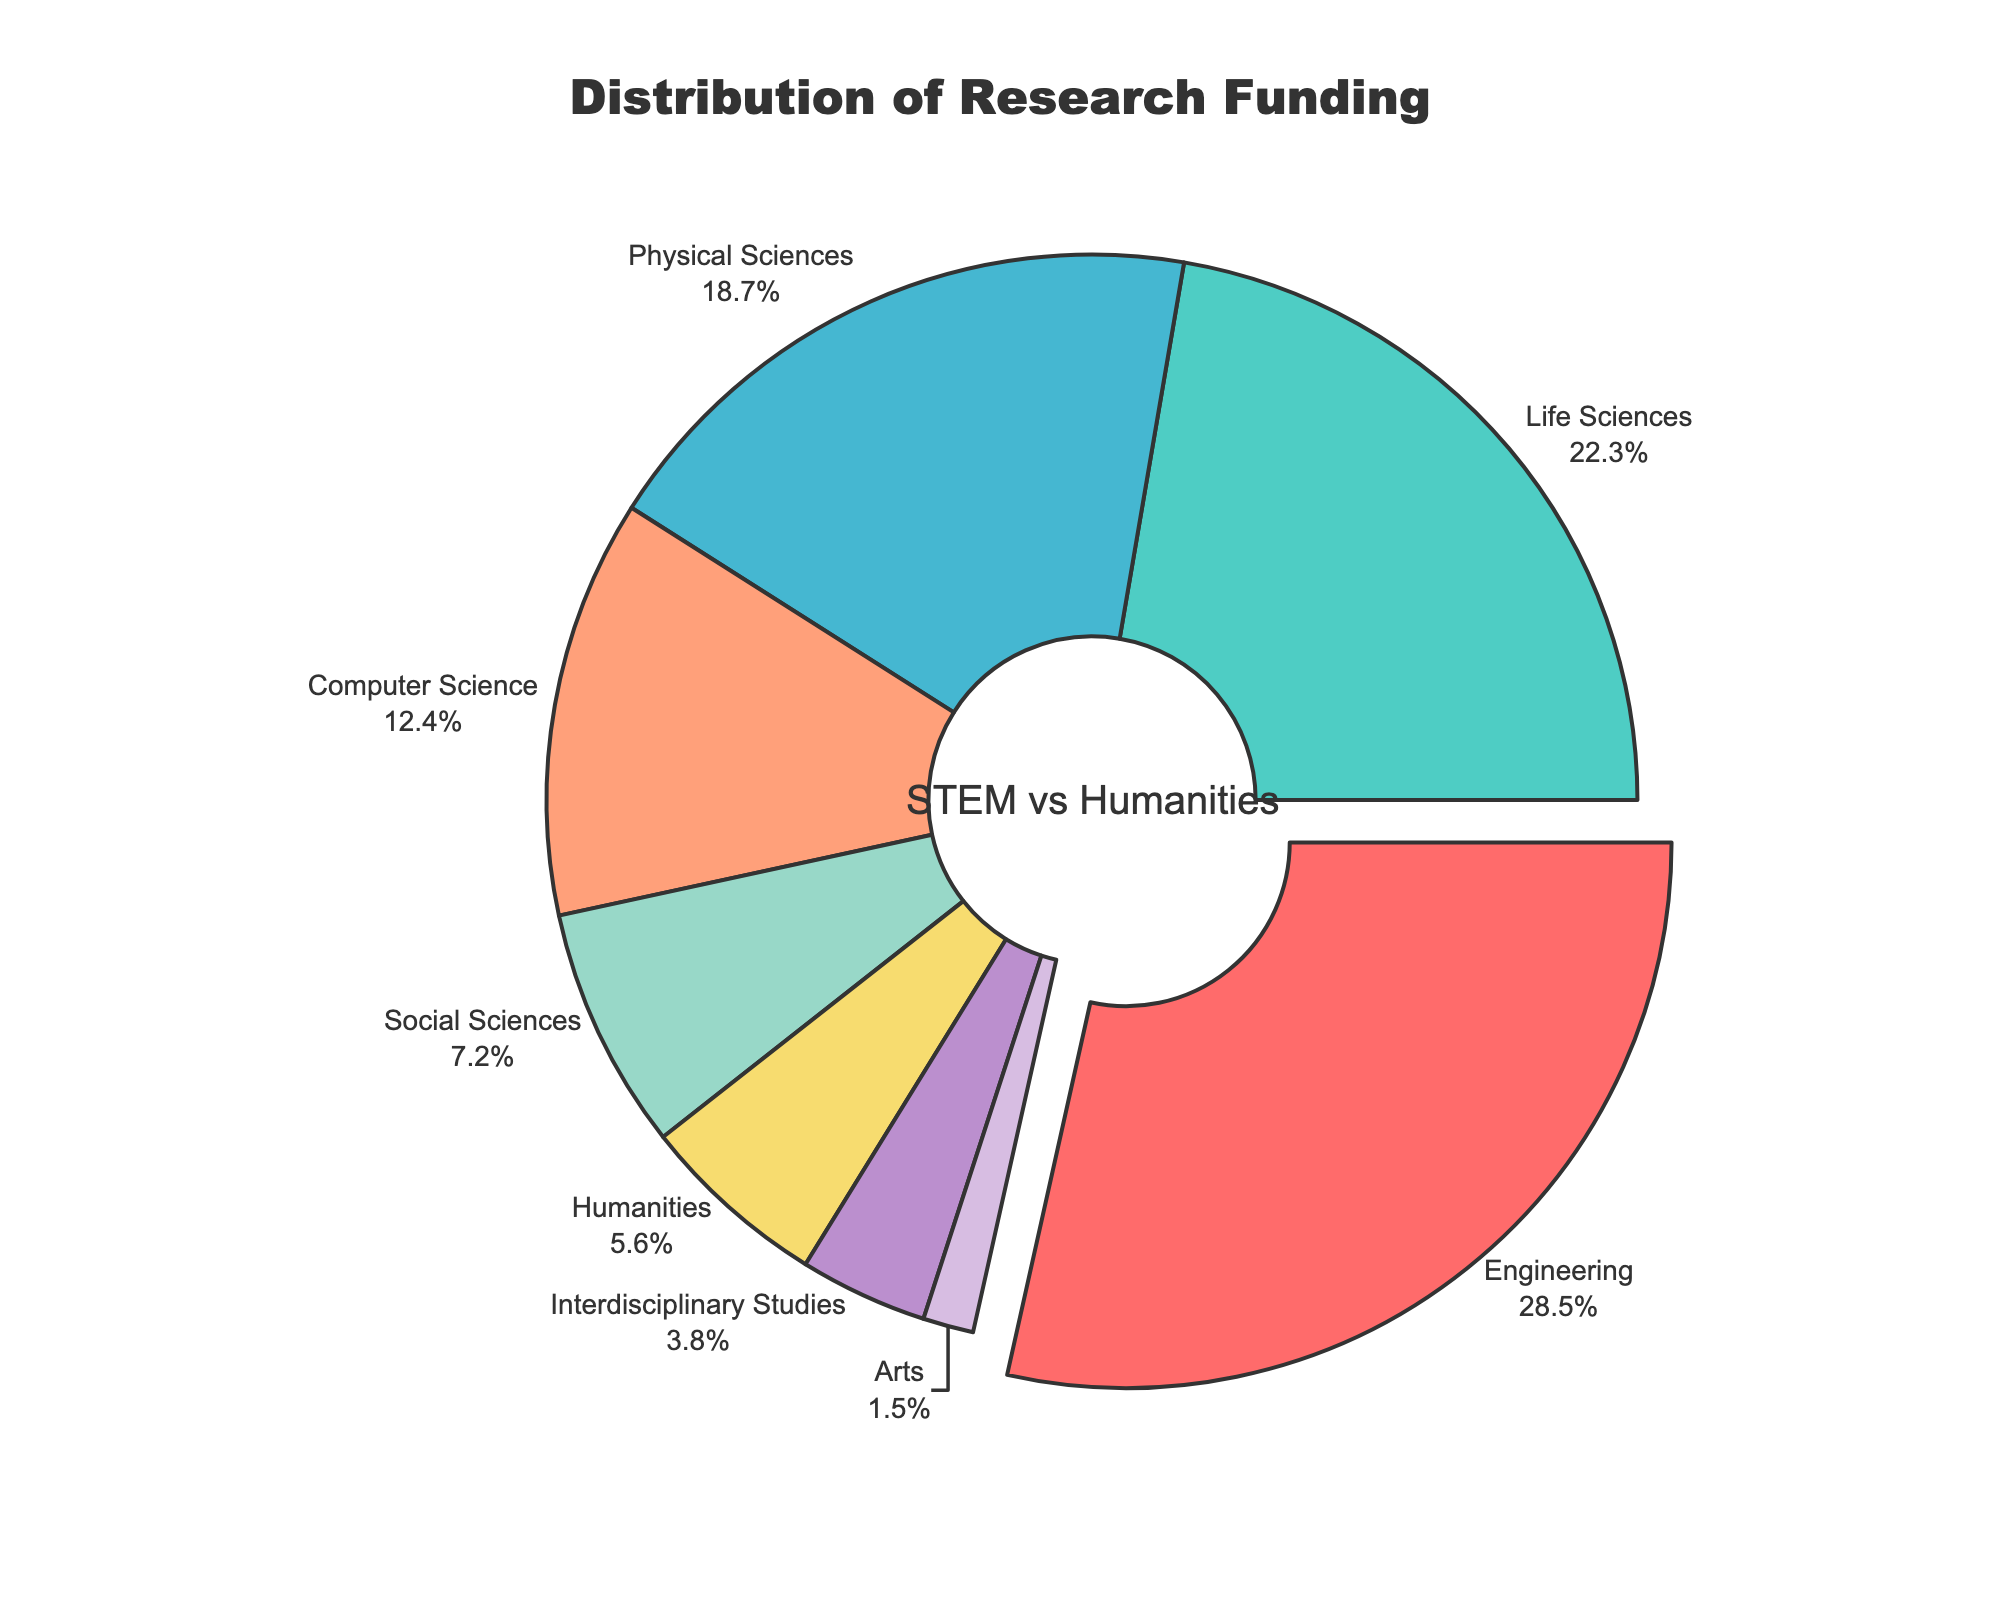What's the percentage of funding allocated to Humanities? The slice labeled "Humanities" has a corresponding percentage value.
Answer: 5.6% Which discipline receives the highest proportion of funding? By observing the largest slice of the pie chart, we identify the discipline with the greatest percentage value.
Answer: Engineering What is the combined funding percentage for Life Sciences and Physical Sciences? Add up the funding percentages for Life Sciences (22.3%) and Physical Sciences (18.7%). So, 22.3 + 18.7 = 41.0.
Answer: 41.0% Compare the funding received by Computer Science and Social Sciences. Which one gets more? By comparing the sizes and percentages of their respective slices, we see that Computer Science (12.4%) gets more funding than Social Sciences (7.2%).
Answer: Computer Science What is the difference in funding between the most and least funded disciplines? Identify the highest (Engineering at 28.5%) and lowest (Arts at 1.5%) funded disciplines. Calculate the difference: 28.5% - 1.5%.
Answer: 27.0% Which disciplines have less than 10% of the total funding? Identify the slices with values under 10%: Social Sciences (7.2%), Humanities (5.6%), Interdisciplinary Studies (3.8%), and Arts (1.5%).
Answer: Social Sciences, Humanities, Interdisciplinary Studies, Arts What is the combined percentage of funding for STEM disciplines (Engineering, Life Sciences, Physical Sciences, and Computer Science)? Sum the percentages for Engineering (28.5%), Life Sciences (22.3%), Physical Sciences (18.7%), and Computer Science (12.4%). So, 28.5 + 22.3 + 18.7 + 12.4 = 81.9.
Answer: 81.9% Which discipline gets nearly double the funding of Social Sciences? Social Sciences receive 7.2%. Compare this with other slices to find that Computer Science receives 12.4%, which is nearly double.
Answer: Computer Science What is the ratio of funding between Life Sciences and Interdisciplinary Studies? Divide the percentage of Life Sciences (22.3%) by that of Interdisciplinary Studies (3.8%). So, 22.3 / 3.8 ≈ 5.87.
Answer: Approximately 5.87 Identify the discipline represented by the yellow slice. The yellow slice corresponds to the slice labeled as "Physical Sciences".
Answer: Physical Sciences 